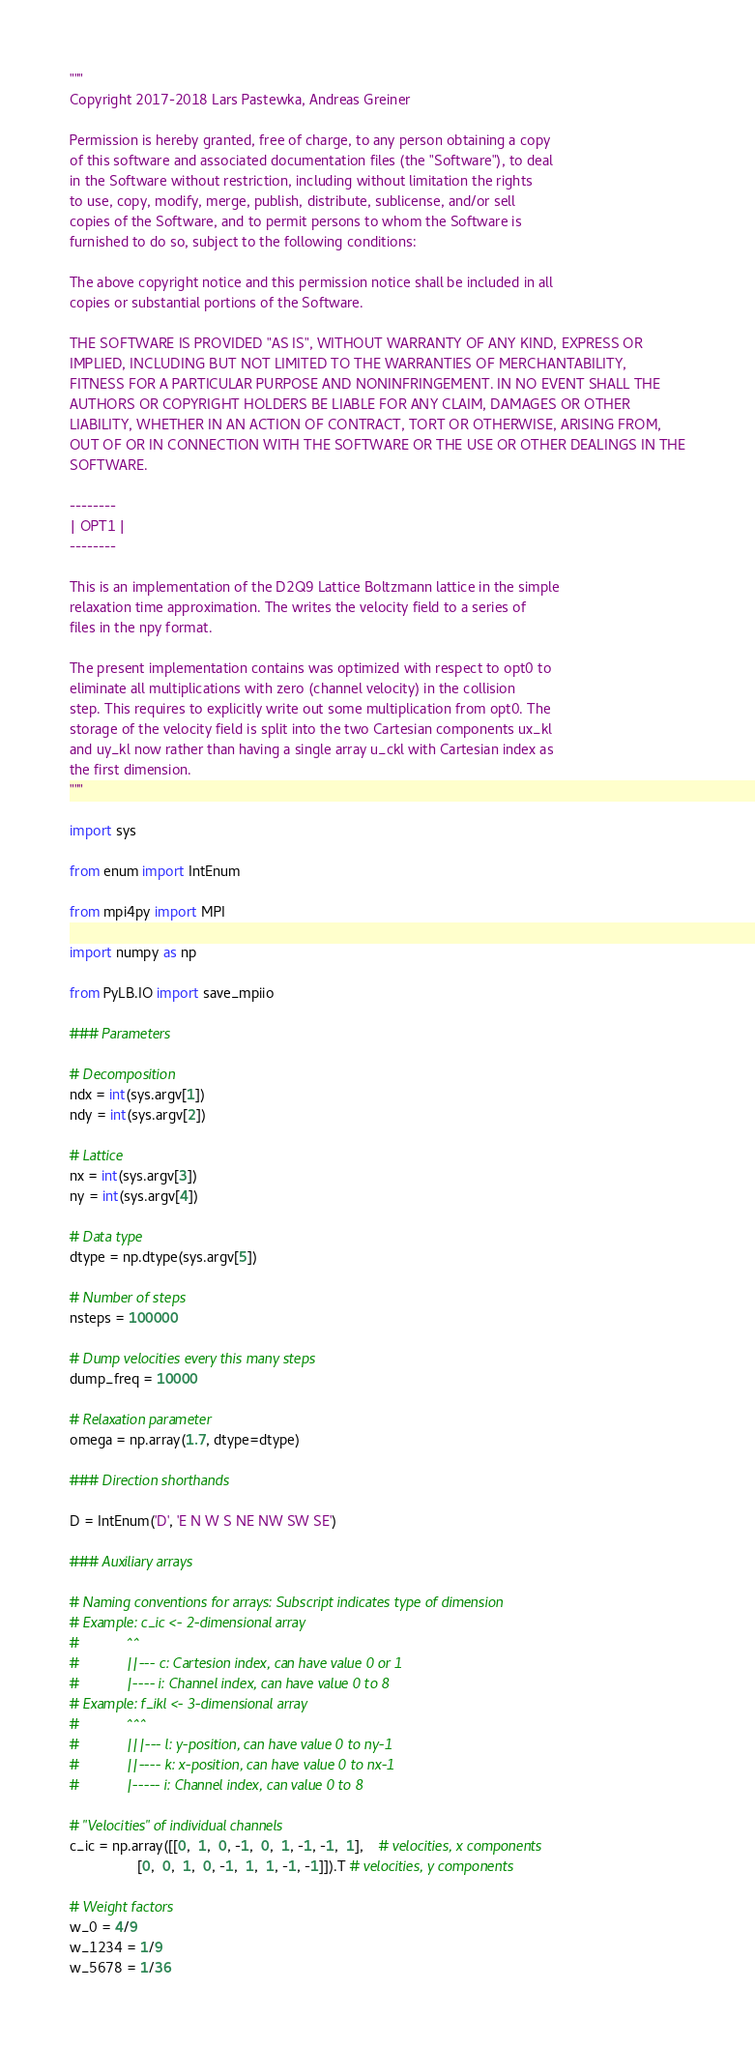<code> <loc_0><loc_0><loc_500><loc_500><_Python_>"""
Copyright 2017-2018 Lars Pastewka, Andreas Greiner

Permission is hereby granted, free of charge, to any person obtaining a copy
of this software and associated documentation files (the "Software"), to deal
in the Software without restriction, including without limitation the rights
to use, copy, modify, merge, publish, distribute, sublicense, and/or sell
copies of the Software, and to permit persons to whom the Software is
furnished to do so, subject to the following conditions:

The above copyright notice and this permission notice shall be included in all
copies or substantial portions of the Software.

THE SOFTWARE IS PROVIDED "AS IS", WITHOUT WARRANTY OF ANY KIND, EXPRESS OR
IMPLIED, INCLUDING BUT NOT LIMITED TO THE WARRANTIES OF MERCHANTABILITY,
FITNESS FOR A PARTICULAR PURPOSE AND NONINFRINGEMENT. IN NO EVENT SHALL THE
AUTHORS OR COPYRIGHT HOLDERS BE LIABLE FOR ANY CLAIM, DAMAGES OR OTHER
LIABILITY, WHETHER IN AN ACTION OF CONTRACT, TORT OR OTHERWISE, ARISING FROM,
OUT OF OR IN CONNECTION WITH THE SOFTWARE OR THE USE OR OTHER DEALINGS IN THE
SOFTWARE.

--------
| OPT1 |
--------

This is an implementation of the D2Q9 Lattice Boltzmann lattice in the simple
relaxation time approximation. The writes the velocity field to a series of
files in the npy format.

The present implementation contains was optimized with respect to opt0 to
eliminate all multiplications with zero (channel velocity) in the collision
step. This requires to explicitly write out some multiplication from opt0. The
storage of the velocity field is split into the two Cartesian components ux_kl
and uy_kl now rather than having a single array u_ckl with Cartesian index as
the first dimension.
"""

import sys

from enum import IntEnum

from mpi4py import MPI

import numpy as np

from PyLB.IO import save_mpiio

### Parameters

# Decomposition
ndx = int(sys.argv[1])
ndy = int(sys.argv[2])

# Lattice
nx = int(sys.argv[3])
ny = int(sys.argv[4])

# Data type
dtype = np.dtype(sys.argv[5])

# Number of steps
nsteps = 100000

# Dump velocities every this many steps
dump_freq = 10000

# Relaxation parameter
omega = np.array(1.7, dtype=dtype)

### Direction shorthands

D = IntEnum('D', 'E N W S NE NW SW SE')

### Auxiliary arrays

# Naming conventions for arrays: Subscript indicates type of dimension
# Example: c_ic <- 2-dimensional array
#            ^^
#            ||--- c: Cartesion index, can have value 0 or 1
#            |---- i: Channel index, can have value 0 to 8
# Example: f_ikl <- 3-dimensional array
#            ^^^
#            |||--- l: y-position, can have value 0 to ny-1
#            ||---- k: x-position, can have value 0 to nx-1
#            |----- i: Channel index, can value 0 to 8

# "Velocities" of individual channels
c_ic = np.array([[0,  1,  0, -1,  0,  1, -1, -1,  1],    # velocities, x components
                 [0,  0,  1,  0, -1,  1,  1, -1, -1]]).T # velocities, y components

# Weight factors
w_0 = 4/9
w_1234 = 1/9
w_5678 = 1/36</code> 